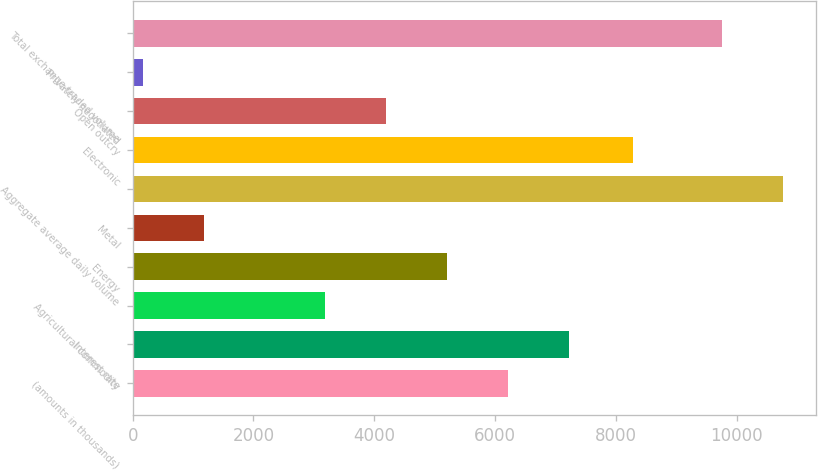Convert chart. <chart><loc_0><loc_0><loc_500><loc_500><bar_chart><fcel>(amounts in thousands)<fcel>Interest rate<fcel>Agricultural commodity<fcel>Energy<fcel>Metal<fcel>Aggregate average daily volume<fcel>Electronic<fcel>Open outcry<fcel>Privately negotiated<fcel>Total exchange-traded volume<nl><fcel>6220.4<fcel>7229.8<fcel>3192.2<fcel>5211<fcel>1173.4<fcel>10773.4<fcel>8290<fcel>4201.6<fcel>164<fcel>9764<nl></chart> 